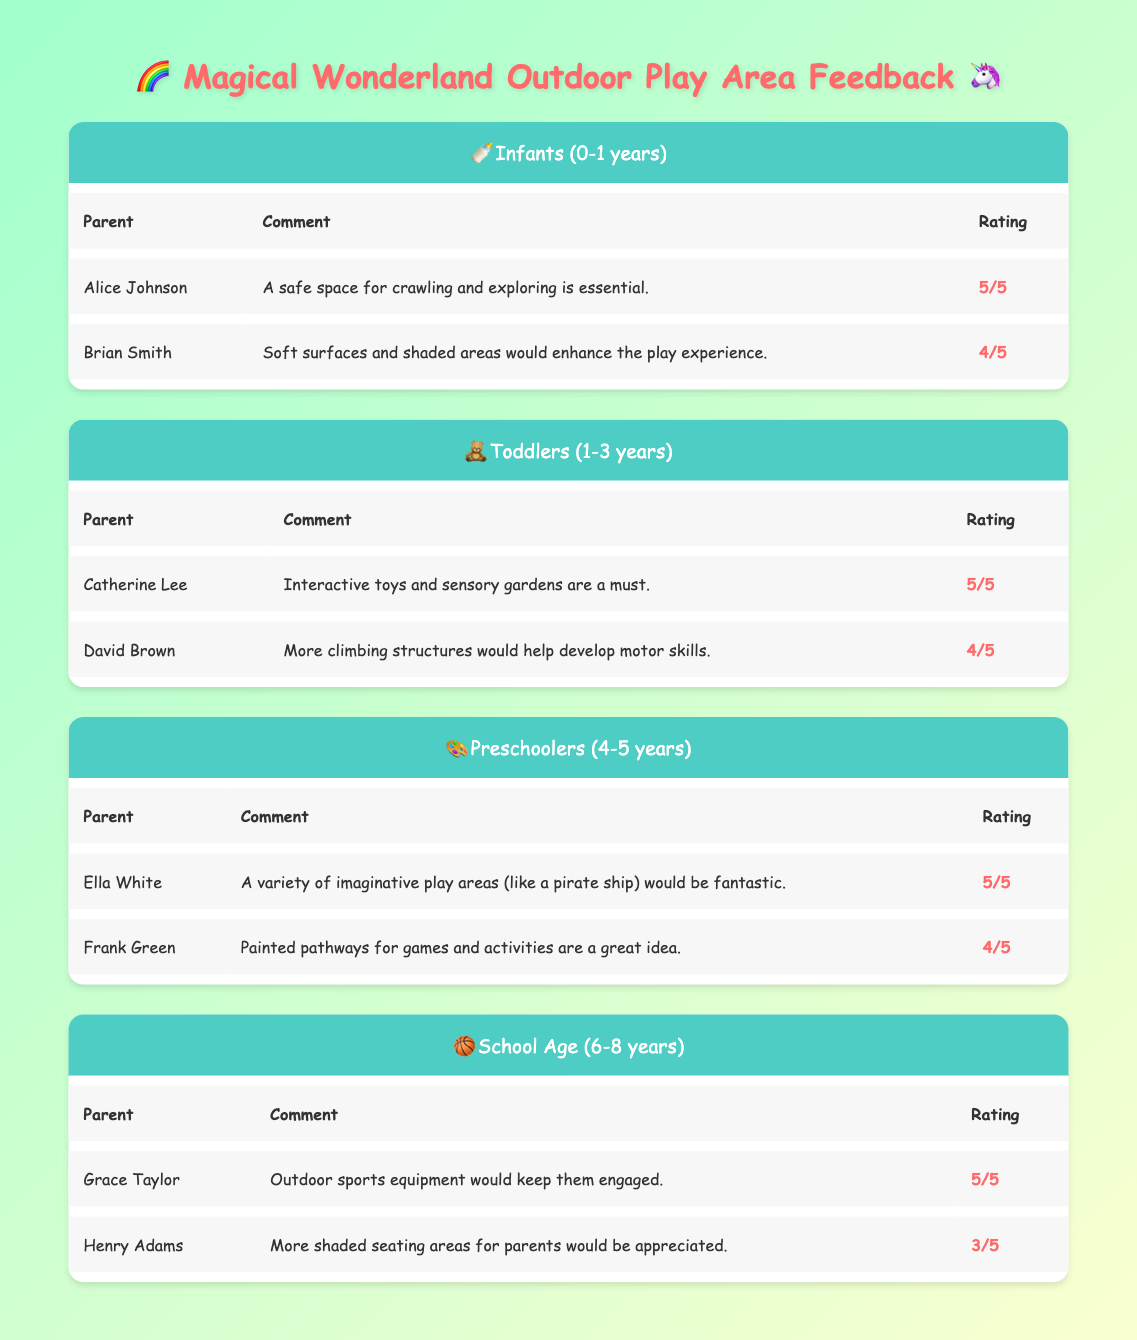What feedback did Alice Johnson provide regarding the outdoor play area? According to the table under the infants' age group, Alice Johnson commented that "A safe space for crawling and exploring is essential."
Answer: A safe space for crawling and exploring is essential How many parents provided feedback for the Toddlers age group? The table lists two feedback entries for the Toddlers age group: one from Catherine Lee and one from David Brown. Thus, the total number of parents who provided feedback is 2.
Answer: 2 What is the average rating for preschoolers based on the feedback? The ratings for preschoolers are 5 (from Ella White) and 4 (from Frank Green). To calculate the average, add the two ratings (5 + 4) = 9, then divide by the number of entries (2): 9/2 = 4.5.
Answer: 4.5 Did any parents suggest that shaded areas would enhance the play experience? Yes, Brian Smith mentioned that "Soft surfaces and shaded areas would enhance the play experience" for the infants' age group, confirming that at least one parent suggested shaded areas.
Answer: Yes What is the highest rating given for the Outdoor Play Area feedback? The highest rating listed in the feedback is 5, which was given by multiple parents: Alice Johnson, Catherine Lee, Ella White, and Grace Taylor.
Answer: 5 